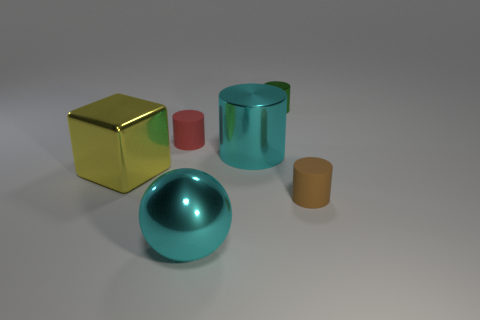How many other objects are there of the same shape as the tiny green shiny thing?
Provide a succinct answer. 3. How big is the brown cylinder?
Give a very brief answer. Small. What is the size of the metal object that is behind the brown cylinder and left of the large cyan cylinder?
Keep it short and to the point. Large. There is a matte object that is left of the small shiny cylinder; what shape is it?
Your response must be concise. Cylinder. Does the cyan ball have the same material as the cyan object that is behind the large yellow shiny thing?
Provide a succinct answer. Yes. Is the shape of the yellow thing the same as the small brown rubber thing?
Your answer should be compact. No. What material is the red object that is the same shape as the green metallic object?
Make the answer very short. Rubber. The cylinder that is both in front of the green cylinder and behind the cyan metal cylinder is what color?
Your response must be concise. Red. What is the color of the shiny sphere?
Offer a terse response. Cyan. There is a big object that is the same color as the large metal sphere; what material is it?
Keep it short and to the point. Metal. 